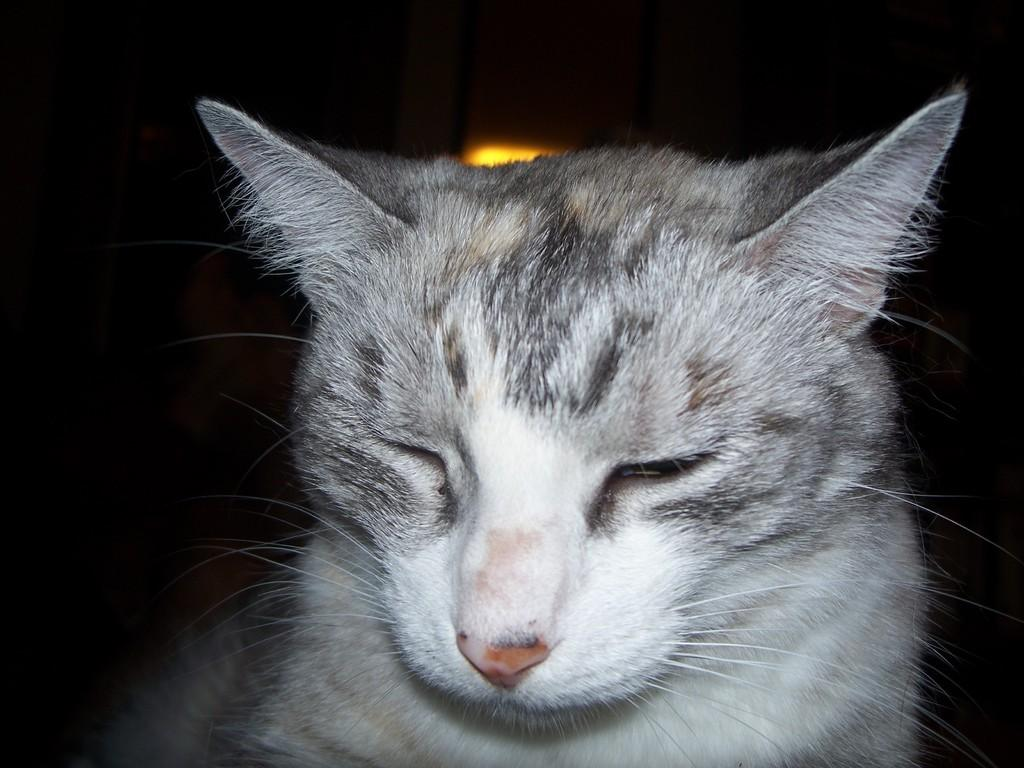What type of animal is in the image? There is a cat in the image. Can you describe the lighting in the image? There is a light source in the image. What is the color or tone of the background in the image? The background of the image is dark. How many brothers can be seen interacting with the cat in the image? There are no brothers present in the image; it only features a cat and a light source. Is there any smoke coming from the stove in the image? There is no stove or smoke present in the image. 